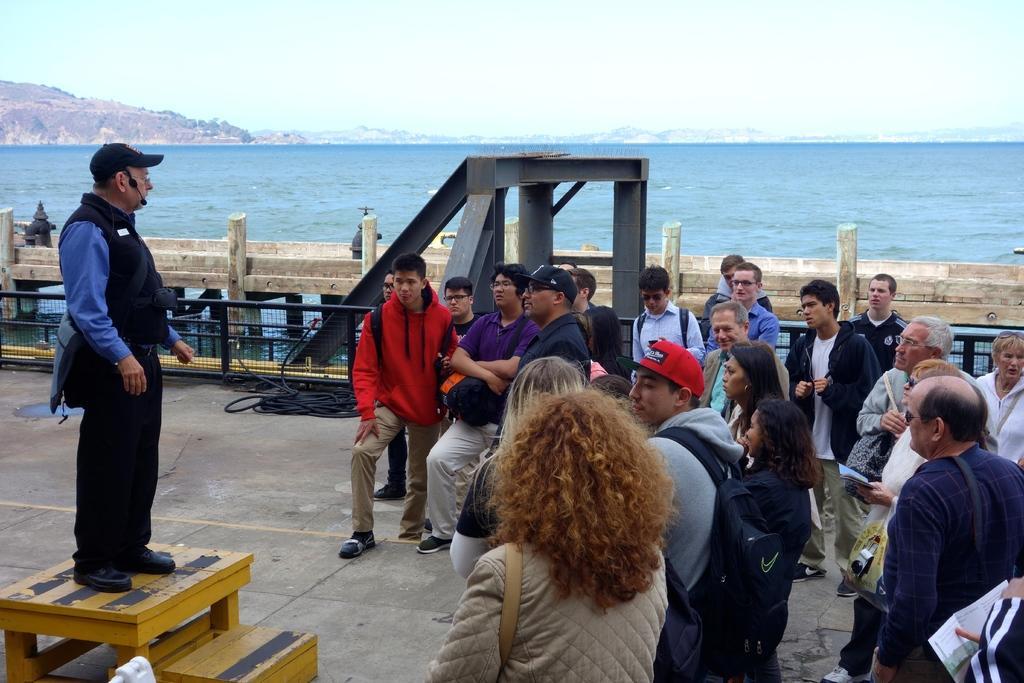How would you summarize this image in a sentence or two? In this picture we can see a group of people listening to the person standing on wooden platform carrying bag worn cap and mic and in the background we can see water, mountains, fence, sky. 